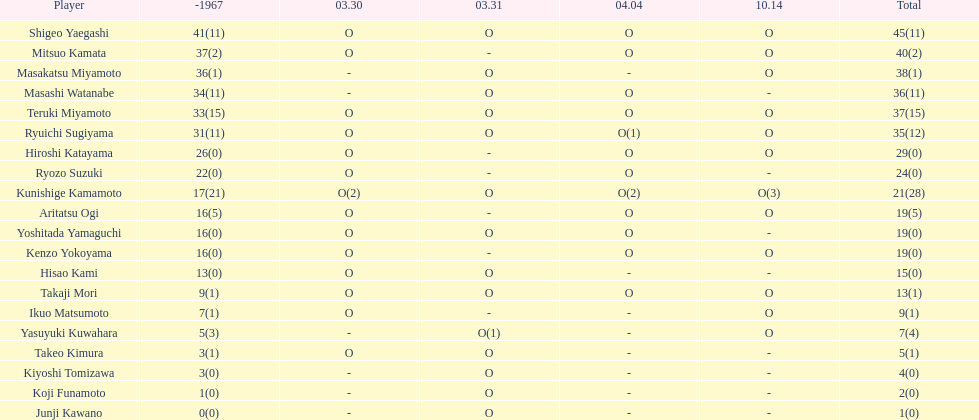Did mitsuo kamata have more than 40 total points? No. 